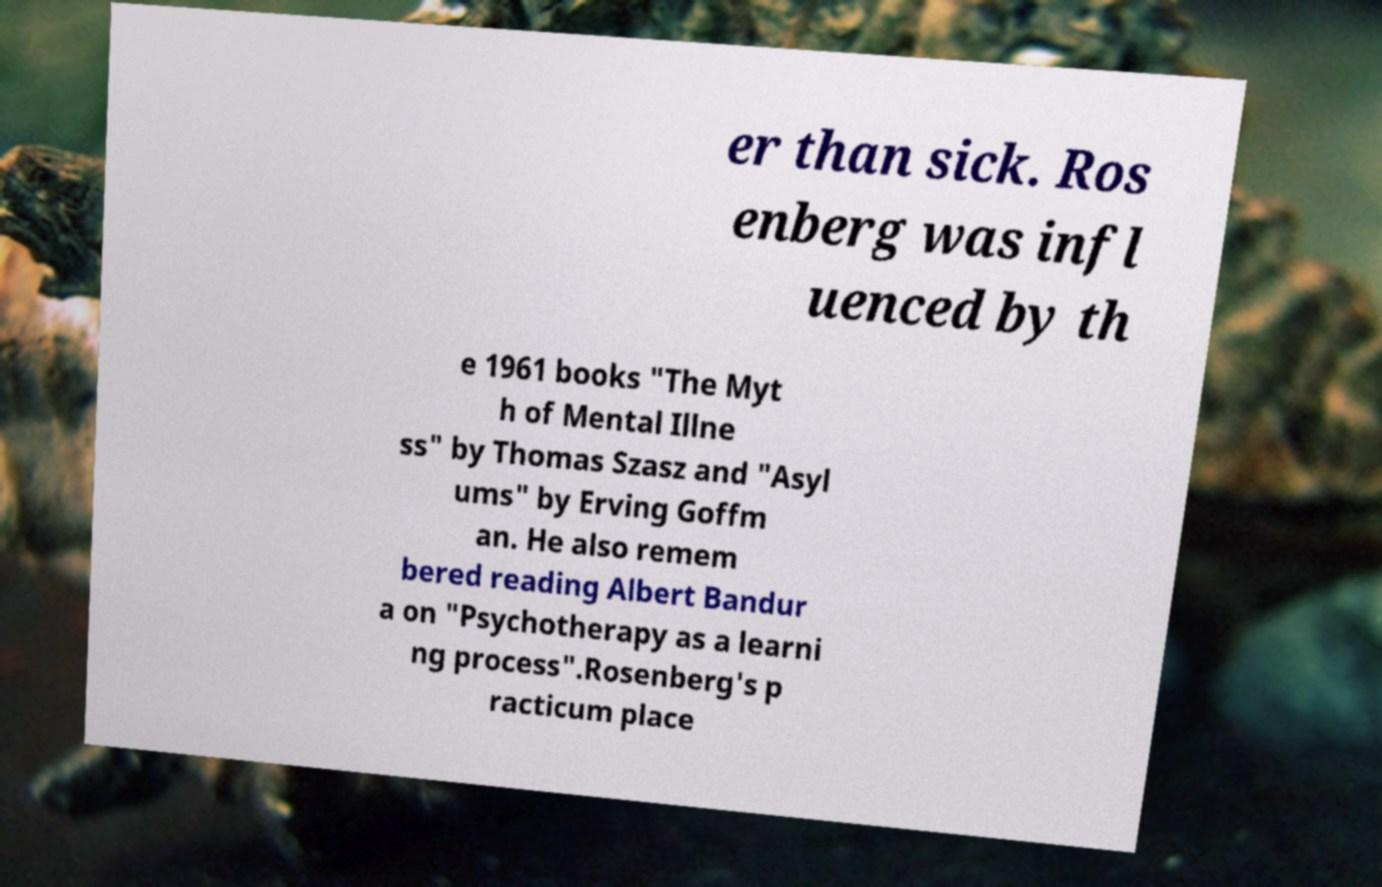What messages or text are displayed in this image? I need them in a readable, typed format. er than sick. Ros enberg was infl uenced by th e 1961 books "The Myt h of Mental Illne ss" by Thomas Szasz and "Asyl ums" by Erving Goffm an. He also remem bered reading Albert Bandur a on "Psychotherapy as a learni ng process".Rosenberg's p racticum place 